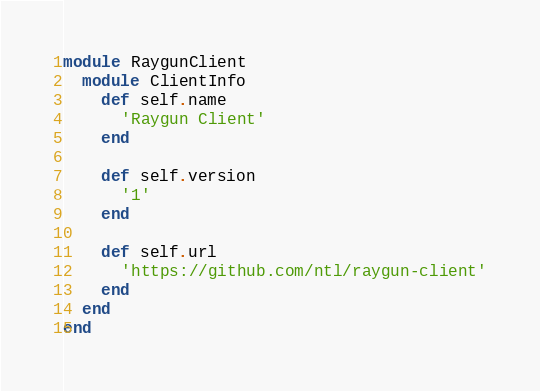<code> <loc_0><loc_0><loc_500><loc_500><_Ruby_>module RaygunClient
  module ClientInfo
    def self.name
      'Raygun Client'
    end

    def self.version
      '1'
    end

    def self.url
      'https://github.com/ntl/raygun-client'
    end
  end
end
</code> 